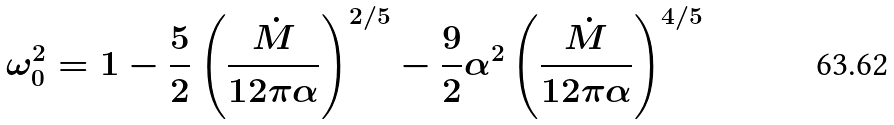Convert formula to latex. <formula><loc_0><loc_0><loc_500><loc_500>\omega _ { 0 } ^ { 2 } = 1 - \frac { 5 } { 2 } \left ( \frac { \dot { M } } { 1 2 \pi \alpha } \right ) ^ { 2 / 5 } - \frac { 9 } { 2 } \alpha ^ { 2 } \left ( \frac { \dot { M } } { 1 2 \pi \alpha } \right ) ^ { 4 / 5 }</formula> 